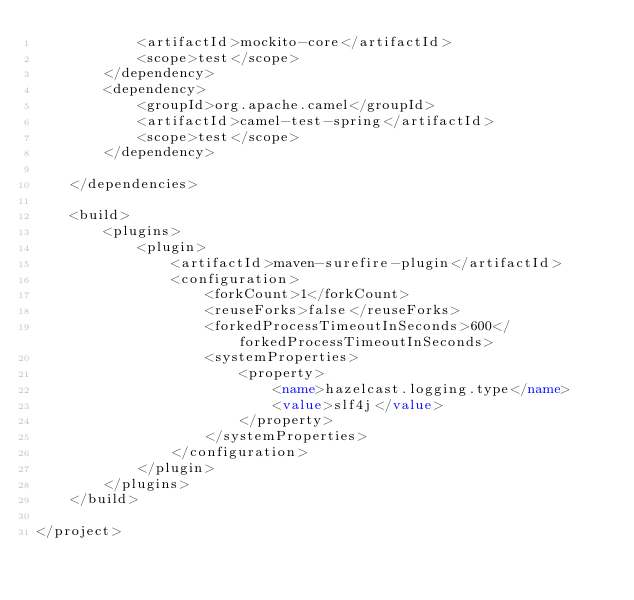Convert code to text. <code><loc_0><loc_0><loc_500><loc_500><_XML_>            <artifactId>mockito-core</artifactId>
            <scope>test</scope>
        </dependency>
        <dependency>
            <groupId>org.apache.camel</groupId>
            <artifactId>camel-test-spring</artifactId>
            <scope>test</scope>
        </dependency>

    </dependencies>

    <build>
        <plugins>
            <plugin>
                <artifactId>maven-surefire-plugin</artifactId>
                <configuration>
                    <forkCount>1</forkCount>
                    <reuseForks>false</reuseForks>
                    <forkedProcessTimeoutInSeconds>600</forkedProcessTimeoutInSeconds>
                    <systemProperties>
                        <property>
                            <name>hazelcast.logging.type</name>
                            <value>slf4j</value>
                        </property>
                    </systemProperties>
                </configuration>
            </plugin>
        </plugins>
    </build>

</project>
</code> 